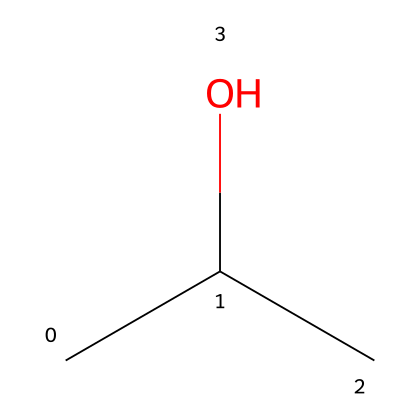What is the name of the compound represented by this SMILES? The SMILES representation "CC(C)O" corresponds to a three-carbon chain with hydroxyl (OH) group, identifying it as isopropyl alcohol.
Answer: isopropyl alcohol How many carbon atoms are in isopropyl alcohol? The SMILES "CC(C)O" indicates three carbon atoms (C), as shown by the three 'C' symbols in the structure.
Answer: three How many hydrogen atoms are present in isopropyl alcohol? Each carbon in the SMILES "CC(C)O" typically bonds with hydrogen. Given a branched structure with three carbons, it has a total of eight hydrogen atoms (C3H8O).
Answer: eight What type of functional group is present in isopropyl alcohol? The presence of the -OH group in "CC(C)O" indicates that this compound contains a hydroxyl functional group, characteristic of alcohols.
Answer: hydroxyl What is a common use of isopropyl alcohol? Isopropyl alcohol is commonly used as a solvent and disinfectant in cleaning products for its effectiveness in killing bacteria and viruses.
Answer: solvent Does isopropyl alcohol have any toxicity concerns? While isopropyl alcohol is widely used, it can be toxic if ingested or in high concentrations, requiring careful handling and storage.
Answer: yes What type of solvent is isopropyl alcohol classified as? Isopropyl alcohol is classified as a polar solvent due to its ability to dissolve both polar and nonpolar substances, making it versatile in cleaning applications.
Answer: polar 